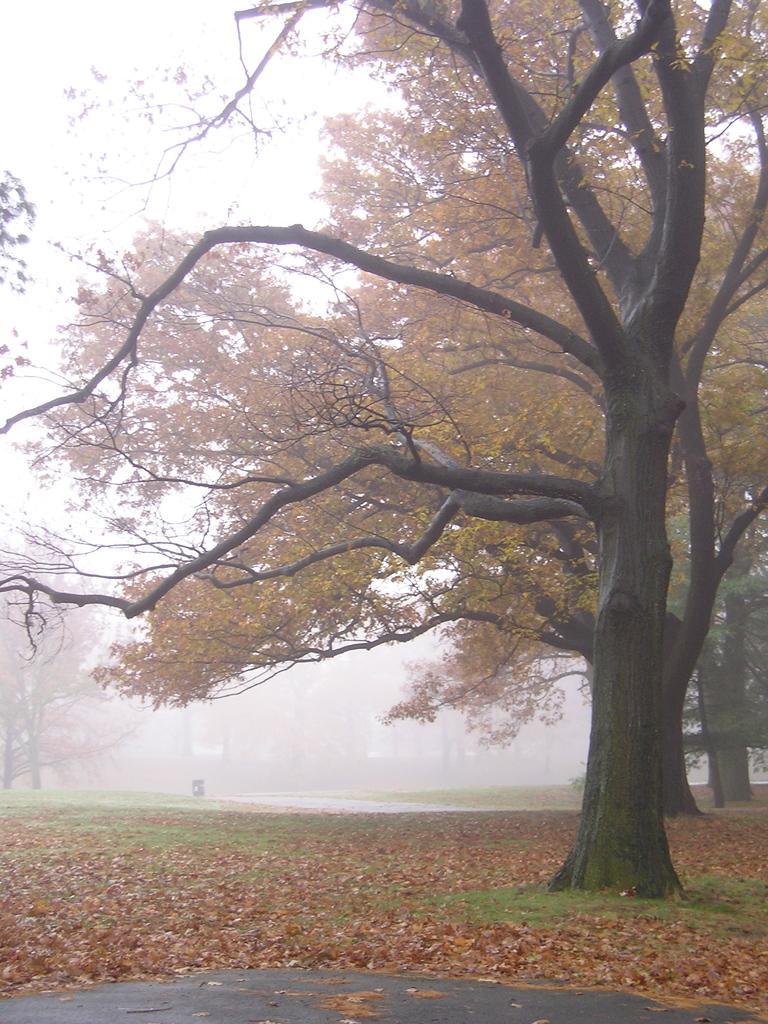Describe this image in one or two sentences. In this image we can see trees. On the ground there are dried leaves.  